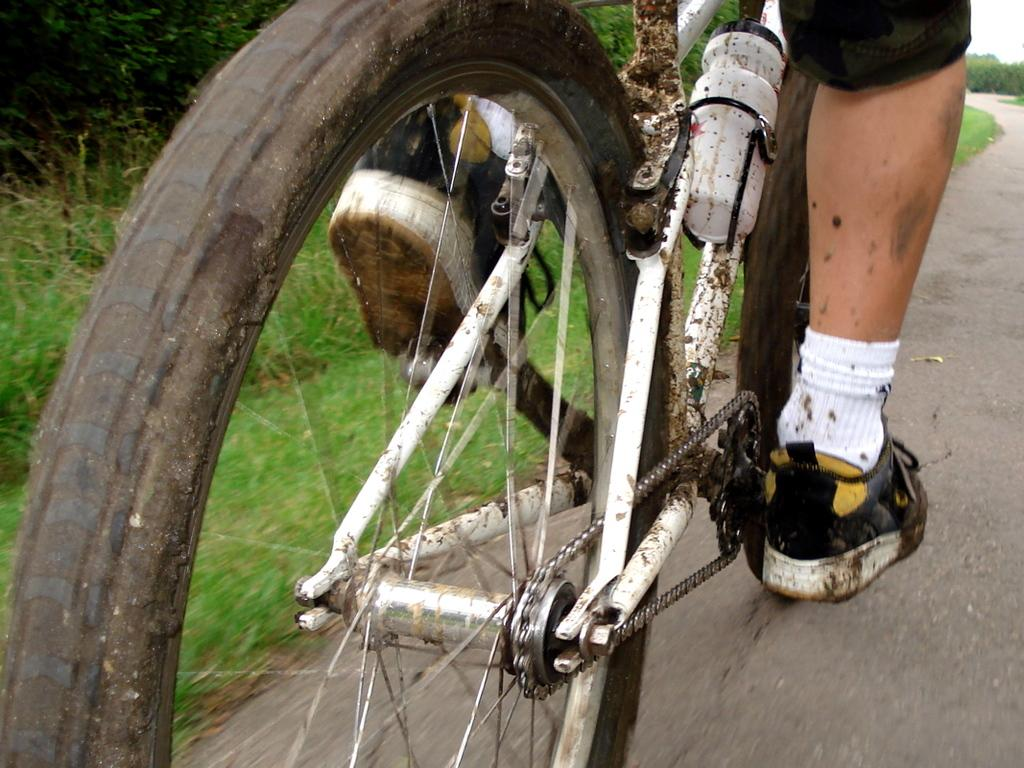What is the person in the image doing? There is a person riding a bicycle in the image. Where is the person riding the bicycle? The person is on the road. What object can be seen in the image besides the bicycle? There is a bottle visible in the image. What type of vegetation is present in the image? Grass is present in the image. What can be seen in the background of the image? There are trees in the background of the image. What type of clouds can be seen in the image? There are no clouds visible in the image; it features a person riding a bicycle on the road. Is there a snake present in the image? No, there is no snake present in the image. 